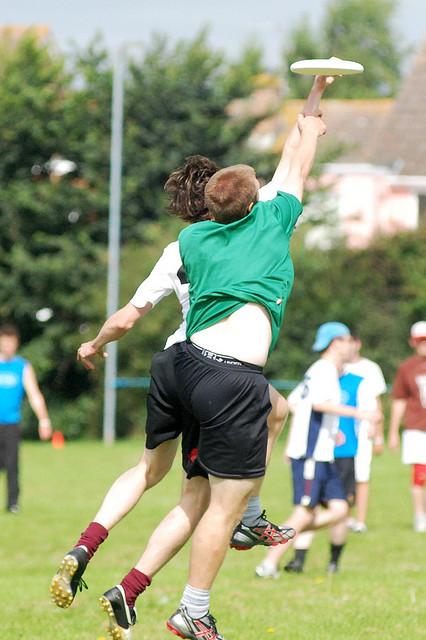What color is the primary person's shirt?
Concise answer only. Green. What type of shoes are they wearing?
Be succinct. Cleats. What are the men trying to catch?
Be succinct. Frisbee. 